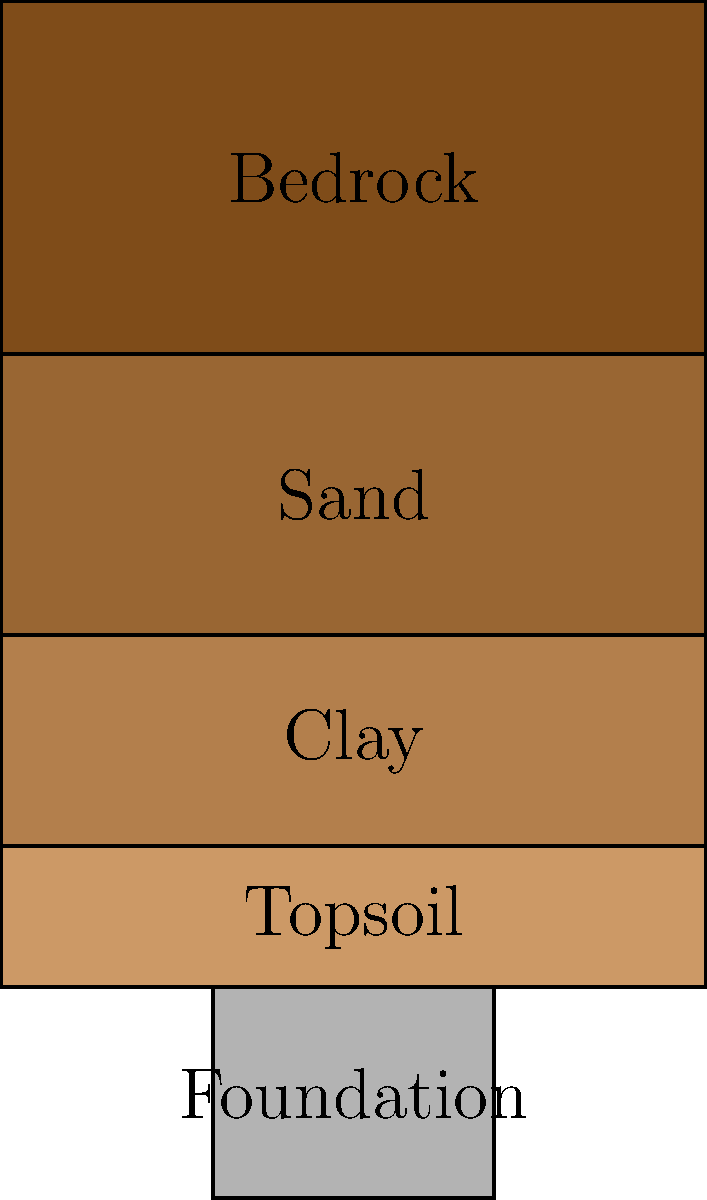In your poetic journey through the layers of life, you encounter a building's foundation resting on varied soil strata. How might the sand layer, nestled between clay and bedrock, influence the stability of this structure's roots? Consider the metaphorical implications for both architecture and the human experience. To understand the impact of the sand layer on the building's foundation, let's explore the soil profile step-by-step:

1. Topsoil: This layer is typically organic and not suitable for supporting foundations due to its compressibility.

2. Clay layer: Clay can be problematic for foundations because it:
   a) Expands when wet and shrinks when dry, causing potential foundation movement.
   b) Has low permeability, which can lead to water accumulation.

3. Sand layer: This is the key layer in question. Sand:
   a) Provides good drainage, allowing water to flow through easily.
   b) Is less prone to volume changes compared to clay.
   c) Can be compacted to create a stable base for foundations.
   d) However, if not properly contained, sand can be prone to erosion or settlement.

4. Bedrock: This is typically the most stable layer, providing solid support for foundations.

The sand layer's influence on the foundation's stability:

1. Positive aspects:
   - Acts as a natural drainage layer, reducing water pressure on the foundation.
   - Provides a more stable base compared to the clay layer above it.

2. Potential concerns:
   - If the sand layer is loose or poorly compacted, it may settle over time, causing foundation movement.
   - Erosion of the sand layer could create voids, potentially leading to foundation instability.

3. Metaphorical implications:
   - The sand layer represents adaptability and flow in life, much like the fluidity in poetry.
   - Just as a poem needs structure (like the clay and bedrock) and flexibility (like the sand), so too does a building's foundation require a balance of stability and adaptability.

In the context of Maya Angelou's work, this soil profile could be seen as a metaphor for the layers of human experience: the topsoil of immediate perceptions, the clay of societal structures, the sand of personal growth and change, and the bedrock of core values and identity.
Answer: The sand layer provides drainage and stability if properly compacted, but may cause settlement or erosion issues if not managed correctly. 